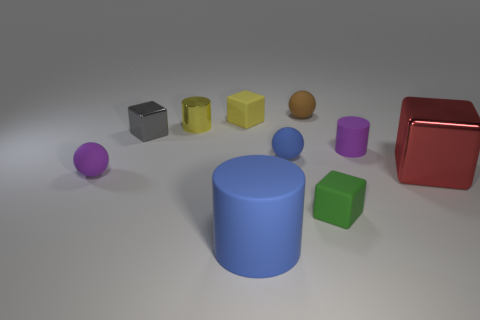Subtract all small blocks. How many blocks are left? 1 Subtract all blue spheres. How many spheres are left? 2 Subtract all purple cylinders. How many red cubes are left? 1 Subtract all cubes. How many objects are left? 6 Subtract 2 cubes. How many cubes are left? 2 Subtract all green balls. Subtract all brown blocks. How many balls are left? 3 Subtract all small blue rubber balls. Subtract all green cubes. How many objects are left? 8 Add 6 brown matte objects. How many brown matte objects are left? 7 Add 1 purple things. How many purple things exist? 3 Subtract 0 red cylinders. How many objects are left? 10 